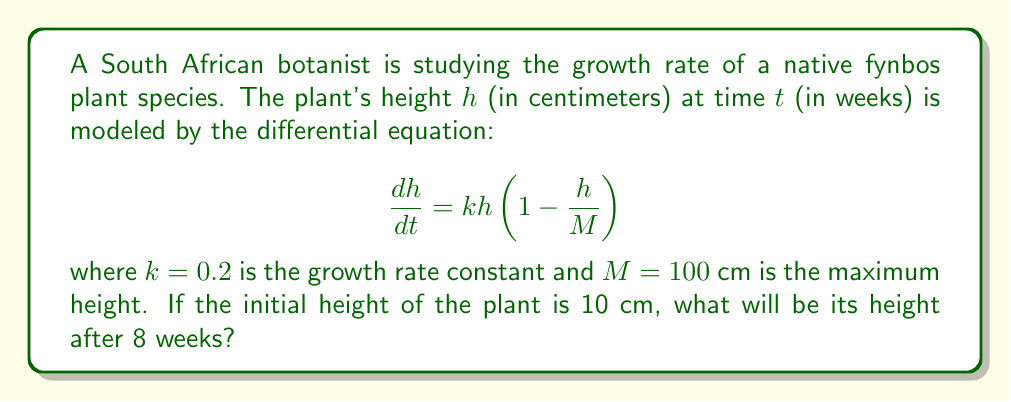Teach me how to tackle this problem. To solve this problem, we need to follow these steps:

1) First, we recognize this differential equation as the logistic growth model.

2) The solution to this equation is given by:

   $$h(t) = \frac{M}{1 + \left(\frac{M}{h_0} - 1\right)e^{-kt}}$$

   where $h_0$ is the initial height.

3) We are given:
   - $M = 100$ cm (maximum height)
   - $k = 0.2$ (growth rate constant)
   - $h_0 = 10$ cm (initial height)
   - $t = 8$ weeks

4) Let's substitute these values into the equation:

   $$h(8) = \frac{100}{1 + \left(\frac{100}{10} - 1\right)e^{-0.2 \cdot 8}}$$

5) Simplify:
   $$h(8) = \frac{100}{1 + 9e^{-1.6}}$$

6) Calculate:
   $$h(8) = \frac{100}{1 + 9 \cdot 0.2019} \approx 35.71$$

Therefore, after 8 weeks, the plant will be approximately 35.71 cm tall.
Answer: 35.71 cm 